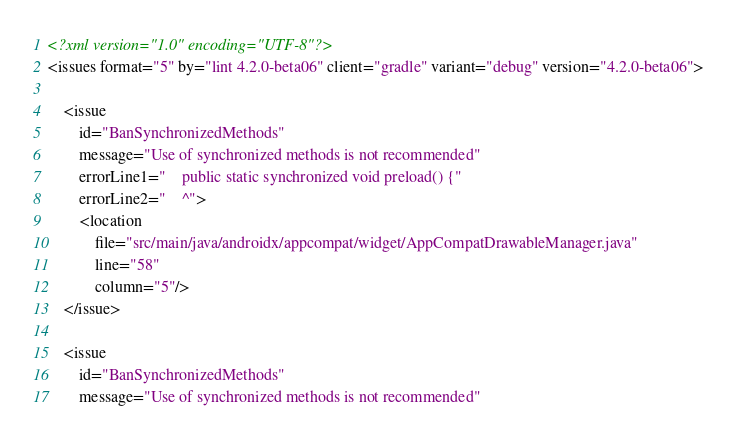Convert code to text. <code><loc_0><loc_0><loc_500><loc_500><_XML_><?xml version="1.0" encoding="UTF-8"?>
<issues format="5" by="lint 4.2.0-beta06" client="gradle" variant="debug" version="4.2.0-beta06">

    <issue
        id="BanSynchronizedMethods"
        message="Use of synchronized methods is not recommended"
        errorLine1="    public static synchronized void preload() {"
        errorLine2="    ^">
        <location
            file="src/main/java/androidx/appcompat/widget/AppCompatDrawableManager.java"
            line="58"
            column="5"/>
    </issue>

    <issue
        id="BanSynchronizedMethods"
        message="Use of synchronized methods is not recommended"</code> 